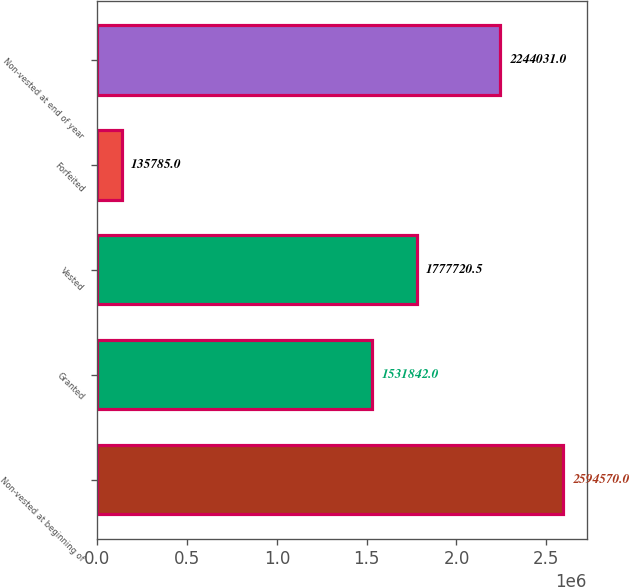Convert chart to OTSL. <chart><loc_0><loc_0><loc_500><loc_500><bar_chart><fcel>Non-vested at beginning of<fcel>Granted<fcel>Vested<fcel>Forfeited<fcel>Non-vested at end of year<nl><fcel>2.59457e+06<fcel>1.53184e+06<fcel>1.77772e+06<fcel>135785<fcel>2.24403e+06<nl></chart> 